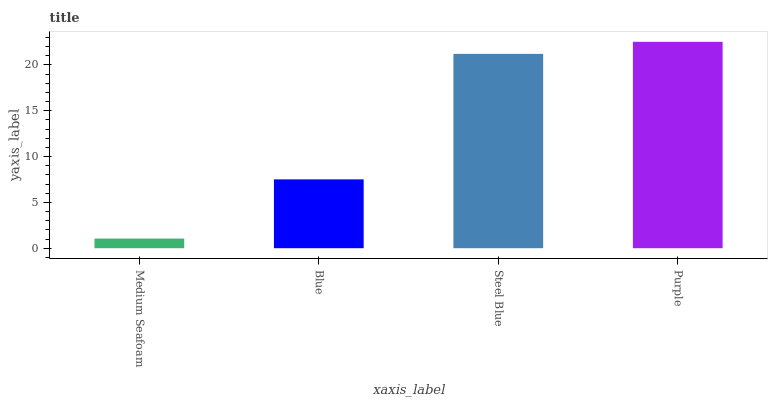Is Medium Seafoam the minimum?
Answer yes or no. Yes. Is Purple the maximum?
Answer yes or no. Yes. Is Blue the minimum?
Answer yes or no. No. Is Blue the maximum?
Answer yes or no. No. Is Blue greater than Medium Seafoam?
Answer yes or no. Yes. Is Medium Seafoam less than Blue?
Answer yes or no. Yes. Is Medium Seafoam greater than Blue?
Answer yes or no. No. Is Blue less than Medium Seafoam?
Answer yes or no. No. Is Steel Blue the high median?
Answer yes or no. Yes. Is Blue the low median?
Answer yes or no. Yes. Is Medium Seafoam the high median?
Answer yes or no. No. Is Purple the low median?
Answer yes or no. No. 